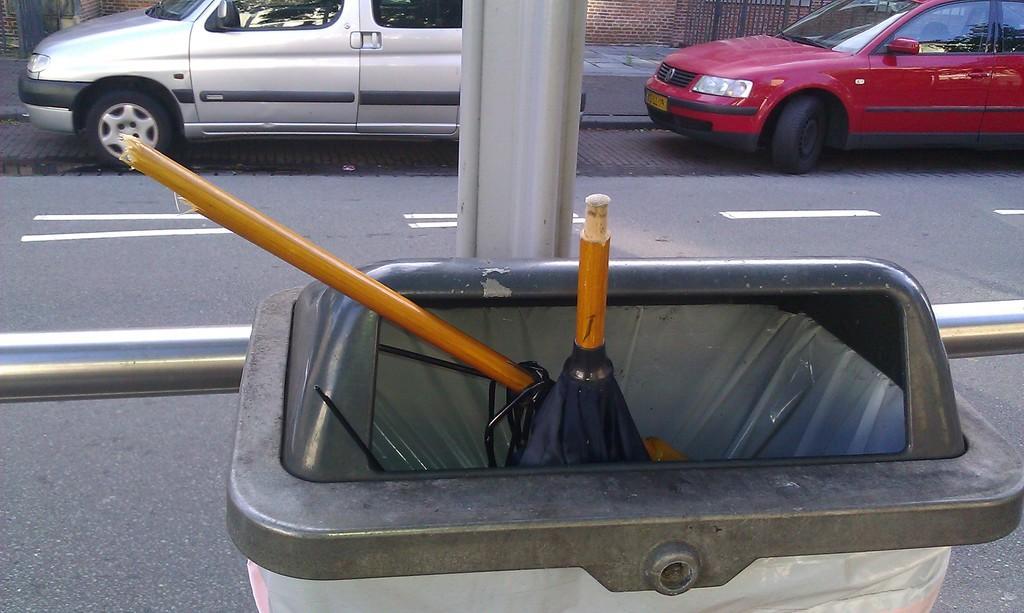Describe this image in one or two sentences. In this image, we can see a dustbin and there is a road, we can see two cars. 